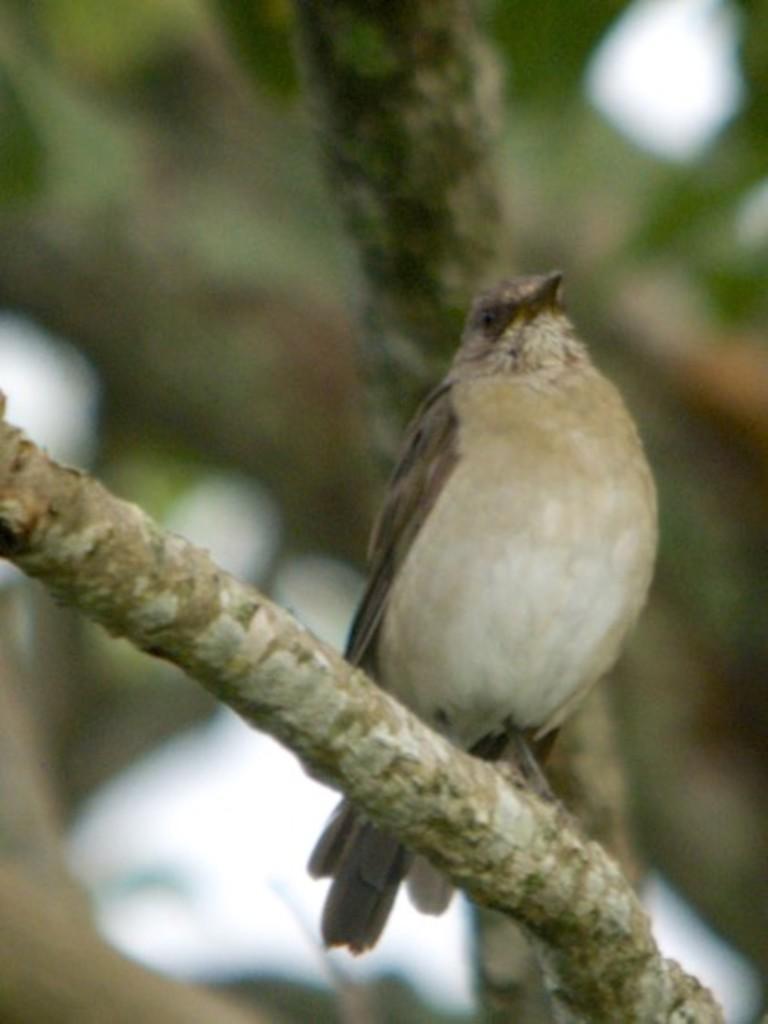Can you describe this image briefly? In this image I can see a bird which is in cream, brown and black color. It is on the branch of the tree and there is a blurred background. 